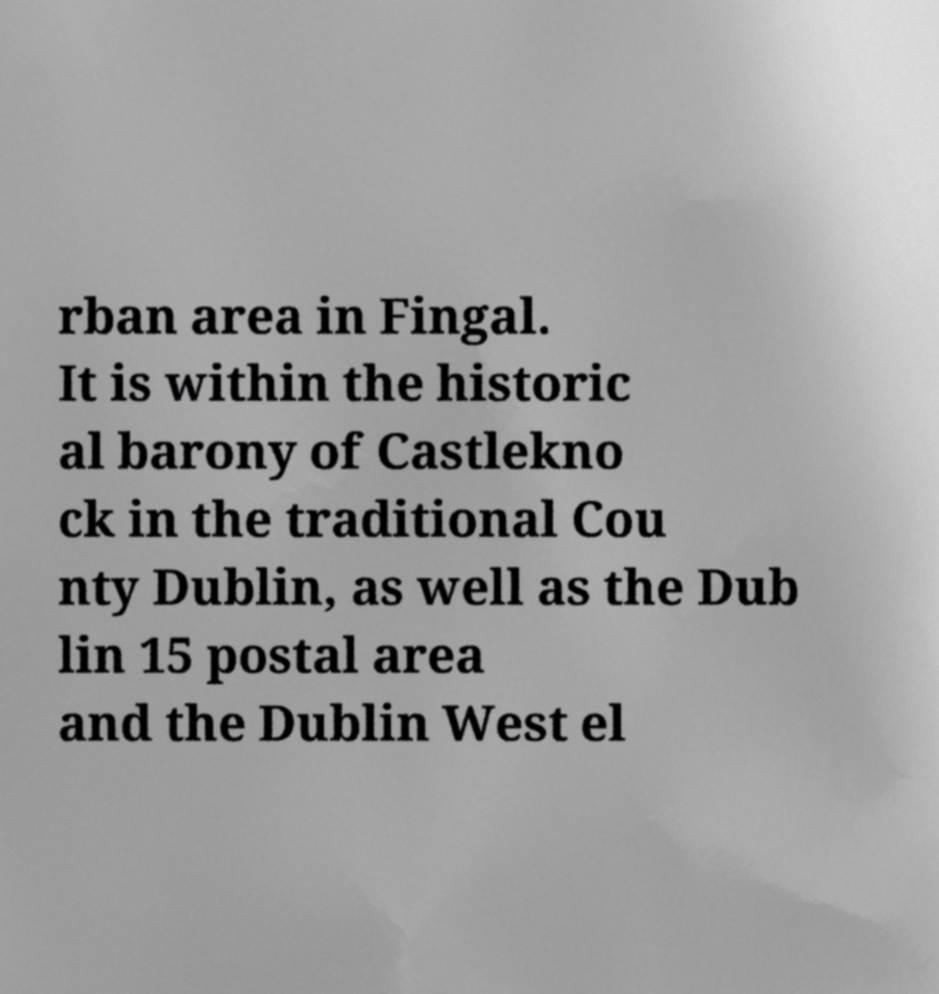For documentation purposes, I need the text within this image transcribed. Could you provide that? rban area in Fingal. It is within the historic al barony of Castlekno ck in the traditional Cou nty Dublin, as well as the Dub lin 15 postal area and the Dublin West el 